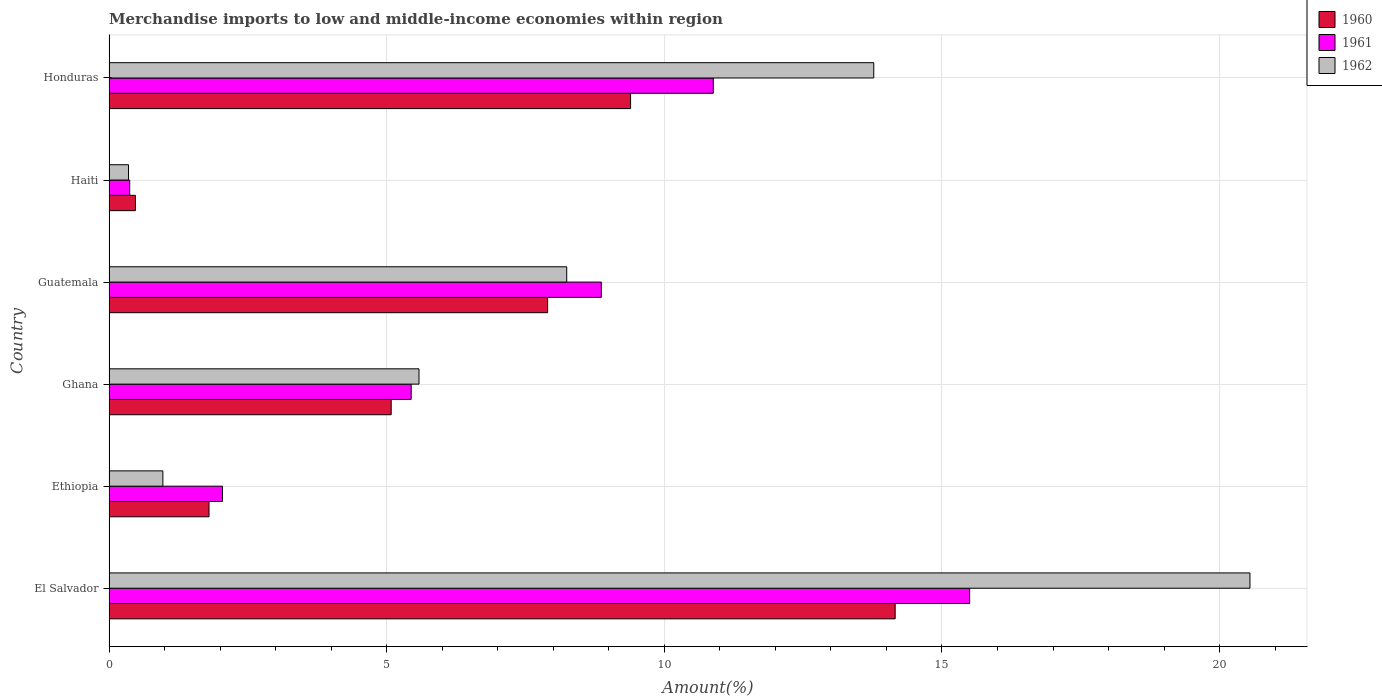How many groups of bars are there?
Ensure brevity in your answer.  6. Are the number of bars per tick equal to the number of legend labels?
Give a very brief answer. Yes. How many bars are there on the 5th tick from the top?
Your response must be concise. 3. How many bars are there on the 2nd tick from the bottom?
Your response must be concise. 3. What is the label of the 1st group of bars from the top?
Keep it short and to the point. Honduras. What is the percentage of amount earned from merchandise imports in 1961 in El Salvador?
Keep it short and to the point. 15.5. Across all countries, what is the maximum percentage of amount earned from merchandise imports in 1961?
Offer a terse response. 15.5. Across all countries, what is the minimum percentage of amount earned from merchandise imports in 1960?
Keep it short and to the point. 0.48. In which country was the percentage of amount earned from merchandise imports in 1961 maximum?
Offer a very short reply. El Salvador. In which country was the percentage of amount earned from merchandise imports in 1960 minimum?
Your answer should be very brief. Haiti. What is the total percentage of amount earned from merchandise imports in 1960 in the graph?
Provide a short and direct response. 38.81. What is the difference between the percentage of amount earned from merchandise imports in 1960 in El Salvador and that in Ethiopia?
Ensure brevity in your answer.  12.36. What is the difference between the percentage of amount earned from merchandise imports in 1962 in Guatemala and the percentage of amount earned from merchandise imports in 1960 in Ghana?
Your answer should be compact. 3.16. What is the average percentage of amount earned from merchandise imports in 1961 per country?
Your response must be concise. 7.18. What is the difference between the percentage of amount earned from merchandise imports in 1960 and percentage of amount earned from merchandise imports in 1962 in Guatemala?
Your answer should be very brief. -0.34. In how many countries, is the percentage of amount earned from merchandise imports in 1962 greater than 6 %?
Give a very brief answer. 3. What is the ratio of the percentage of amount earned from merchandise imports in 1960 in Ethiopia to that in Haiti?
Your response must be concise. 3.79. Is the difference between the percentage of amount earned from merchandise imports in 1960 in El Salvador and Haiti greater than the difference between the percentage of amount earned from merchandise imports in 1962 in El Salvador and Haiti?
Offer a very short reply. No. What is the difference between the highest and the second highest percentage of amount earned from merchandise imports in 1960?
Your response must be concise. 4.76. What is the difference between the highest and the lowest percentage of amount earned from merchandise imports in 1962?
Keep it short and to the point. 20.19. In how many countries, is the percentage of amount earned from merchandise imports in 1961 greater than the average percentage of amount earned from merchandise imports in 1961 taken over all countries?
Your response must be concise. 3. Is the sum of the percentage of amount earned from merchandise imports in 1962 in Ghana and Haiti greater than the maximum percentage of amount earned from merchandise imports in 1961 across all countries?
Offer a terse response. No. How many bars are there?
Offer a very short reply. 18. Are all the bars in the graph horizontal?
Give a very brief answer. Yes. How many countries are there in the graph?
Your answer should be compact. 6. What is the difference between two consecutive major ticks on the X-axis?
Give a very brief answer. 5. Does the graph contain any zero values?
Provide a succinct answer. No. How many legend labels are there?
Your response must be concise. 3. How are the legend labels stacked?
Offer a terse response. Vertical. What is the title of the graph?
Keep it short and to the point. Merchandise imports to low and middle-income economies within region. Does "2012" appear as one of the legend labels in the graph?
Provide a succinct answer. No. What is the label or title of the X-axis?
Make the answer very short. Amount(%). What is the Amount(%) of 1960 in El Salvador?
Your response must be concise. 14.16. What is the Amount(%) in 1961 in El Salvador?
Your response must be concise. 15.5. What is the Amount(%) of 1962 in El Salvador?
Give a very brief answer. 20.55. What is the Amount(%) in 1960 in Ethiopia?
Your answer should be very brief. 1.8. What is the Amount(%) of 1961 in Ethiopia?
Your response must be concise. 2.04. What is the Amount(%) of 1962 in Ethiopia?
Ensure brevity in your answer.  0.97. What is the Amount(%) in 1960 in Ghana?
Ensure brevity in your answer.  5.08. What is the Amount(%) of 1961 in Ghana?
Ensure brevity in your answer.  5.44. What is the Amount(%) of 1962 in Ghana?
Offer a terse response. 5.58. What is the Amount(%) in 1960 in Guatemala?
Your response must be concise. 7.9. What is the Amount(%) of 1961 in Guatemala?
Ensure brevity in your answer.  8.87. What is the Amount(%) in 1962 in Guatemala?
Offer a terse response. 8.24. What is the Amount(%) of 1960 in Haiti?
Provide a short and direct response. 0.48. What is the Amount(%) in 1961 in Haiti?
Your answer should be very brief. 0.37. What is the Amount(%) of 1962 in Haiti?
Make the answer very short. 0.35. What is the Amount(%) of 1960 in Honduras?
Keep it short and to the point. 9.39. What is the Amount(%) of 1961 in Honduras?
Provide a succinct answer. 10.88. What is the Amount(%) in 1962 in Honduras?
Make the answer very short. 13.77. Across all countries, what is the maximum Amount(%) of 1960?
Give a very brief answer. 14.16. Across all countries, what is the maximum Amount(%) of 1961?
Make the answer very short. 15.5. Across all countries, what is the maximum Amount(%) in 1962?
Your answer should be compact. 20.55. Across all countries, what is the minimum Amount(%) in 1960?
Provide a succinct answer. 0.48. Across all countries, what is the minimum Amount(%) in 1961?
Offer a very short reply. 0.37. Across all countries, what is the minimum Amount(%) in 1962?
Offer a very short reply. 0.35. What is the total Amount(%) of 1960 in the graph?
Your answer should be compact. 38.81. What is the total Amount(%) of 1961 in the graph?
Your answer should be compact. 43.1. What is the total Amount(%) of 1962 in the graph?
Your answer should be very brief. 49.46. What is the difference between the Amount(%) of 1960 in El Salvador and that in Ethiopia?
Offer a very short reply. 12.36. What is the difference between the Amount(%) of 1961 in El Salvador and that in Ethiopia?
Keep it short and to the point. 13.46. What is the difference between the Amount(%) in 1962 in El Salvador and that in Ethiopia?
Provide a short and direct response. 19.58. What is the difference between the Amount(%) in 1960 in El Salvador and that in Ghana?
Provide a succinct answer. 9.08. What is the difference between the Amount(%) in 1961 in El Salvador and that in Ghana?
Your response must be concise. 10.06. What is the difference between the Amount(%) in 1962 in El Salvador and that in Ghana?
Your answer should be compact. 14.96. What is the difference between the Amount(%) in 1960 in El Salvador and that in Guatemala?
Offer a terse response. 6.26. What is the difference between the Amount(%) of 1961 in El Salvador and that in Guatemala?
Provide a short and direct response. 6.63. What is the difference between the Amount(%) of 1962 in El Salvador and that in Guatemala?
Give a very brief answer. 12.3. What is the difference between the Amount(%) in 1960 in El Salvador and that in Haiti?
Offer a terse response. 13.68. What is the difference between the Amount(%) of 1961 in El Salvador and that in Haiti?
Your answer should be very brief. 15.13. What is the difference between the Amount(%) in 1962 in El Salvador and that in Haiti?
Your answer should be compact. 20.19. What is the difference between the Amount(%) of 1960 in El Salvador and that in Honduras?
Keep it short and to the point. 4.76. What is the difference between the Amount(%) of 1961 in El Salvador and that in Honduras?
Your answer should be compact. 4.62. What is the difference between the Amount(%) of 1962 in El Salvador and that in Honduras?
Your answer should be compact. 6.77. What is the difference between the Amount(%) in 1960 in Ethiopia and that in Ghana?
Keep it short and to the point. -3.28. What is the difference between the Amount(%) of 1961 in Ethiopia and that in Ghana?
Your response must be concise. -3.4. What is the difference between the Amount(%) in 1962 in Ethiopia and that in Ghana?
Make the answer very short. -4.61. What is the difference between the Amount(%) of 1960 in Ethiopia and that in Guatemala?
Your answer should be compact. -6.1. What is the difference between the Amount(%) in 1961 in Ethiopia and that in Guatemala?
Make the answer very short. -6.82. What is the difference between the Amount(%) of 1962 in Ethiopia and that in Guatemala?
Your answer should be compact. -7.27. What is the difference between the Amount(%) in 1960 in Ethiopia and that in Haiti?
Your response must be concise. 1.33. What is the difference between the Amount(%) in 1961 in Ethiopia and that in Haiti?
Provide a short and direct response. 1.67. What is the difference between the Amount(%) of 1962 in Ethiopia and that in Haiti?
Provide a succinct answer. 0.62. What is the difference between the Amount(%) of 1960 in Ethiopia and that in Honduras?
Provide a succinct answer. -7.59. What is the difference between the Amount(%) of 1961 in Ethiopia and that in Honduras?
Ensure brevity in your answer.  -8.84. What is the difference between the Amount(%) of 1962 in Ethiopia and that in Honduras?
Make the answer very short. -12.8. What is the difference between the Amount(%) of 1960 in Ghana and that in Guatemala?
Provide a succinct answer. -2.82. What is the difference between the Amount(%) of 1961 in Ghana and that in Guatemala?
Your response must be concise. -3.42. What is the difference between the Amount(%) in 1962 in Ghana and that in Guatemala?
Offer a very short reply. -2.66. What is the difference between the Amount(%) in 1960 in Ghana and that in Haiti?
Your answer should be very brief. 4.61. What is the difference between the Amount(%) of 1961 in Ghana and that in Haiti?
Your response must be concise. 5.07. What is the difference between the Amount(%) in 1962 in Ghana and that in Haiti?
Your answer should be very brief. 5.23. What is the difference between the Amount(%) of 1960 in Ghana and that in Honduras?
Provide a short and direct response. -4.31. What is the difference between the Amount(%) of 1961 in Ghana and that in Honduras?
Offer a very short reply. -5.44. What is the difference between the Amount(%) of 1962 in Ghana and that in Honduras?
Provide a succinct answer. -8.19. What is the difference between the Amount(%) in 1960 in Guatemala and that in Haiti?
Make the answer very short. 7.42. What is the difference between the Amount(%) in 1961 in Guatemala and that in Haiti?
Offer a very short reply. 8.49. What is the difference between the Amount(%) in 1962 in Guatemala and that in Haiti?
Provide a succinct answer. 7.89. What is the difference between the Amount(%) of 1960 in Guatemala and that in Honduras?
Ensure brevity in your answer.  -1.49. What is the difference between the Amount(%) in 1961 in Guatemala and that in Honduras?
Give a very brief answer. -2.02. What is the difference between the Amount(%) in 1962 in Guatemala and that in Honduras?
Your response must be concise. -5.53. What is the difference between the Amount(%) of 1960 in Haiti and that in Honduras?
Provide a succinct answer. -8.92. What is the difference between the Amount(%) of 1961 in Haiti and that in Honduras?
Keep it short and to the point. -10.51. What is the difference between the Amount(%) of 1962 in Haiti and that in Honduras?
Your response must be concise. -13.42. What is the difference between the Amount(%) in 1960 in El Salvador and the Amount(%) in 1961 in Ethiopia?
Provide a succinct answer. 12.11. What is the difference between the Amount(%) of 1960 in El Salvador and the Amount(%) of 1962 in Ethiopia?
Your answer should be compact. 13.19. What is the difference between the Amount(%) of 1961 in El Salvador and the Amount(%) of 1962 in Ethiopia?
Offer a terse response. 14.53. What is the difference between the Amount(%) of 1960 in El Salvador and the Amount(%) of 1961 in Ghana?
Your answer should be very brief. 8.72. What is the difference between the Amount(%) of 1960 in El Salvador and the Amount(%) of 1962 in Ghana?
Make the answer very short. 8.57. What is the difference between the Amount(%) of 1961 in El Salvador and the Amount(%) of 1962 in Ghana?
Offer a terse response. 9.92. What is the difference between the Amount(%) of 1960 in El Salvador and the Amount(%) of 1961 in Guatemala?
Give a very brief answer. 5.29. What is the difference between the Amount(%) of 1960 in El Salvador and the Amount(%) of 1962 in Guatemala?
Offer a very short reply. 5.92. What is the difference between the Amount(%) of 1961 in El Salvador and the Amount(%) of 1962 in Guatemala?
Provide a short and direct response. 7.26. What is the difference between the Amount(%) of 1960 in El Salvador and the Amount(%) of 1961 in Haiti?
Ensure brevity in your answer.  13.78. What is the difference between the Amount(%) in 1960 in El Salvador and the Amount(%) in 1962 in Haiti?
Keep it short and to the point. 13.81. What is the difference between the Amount(%) of 1961 in El Salvador and the Amount(%) of 1962 in Haiti?
Ensure brevity in your answer.  15.15. What is the difference between the Amount(%) of 1960 in El Salvador and the Amount(%) of 1961 in Honduras?
Keep it short and to the point. 3.28. What is the difference between the Amount(%) in 1960 in El Salvador and the Amount(%) in 1962 in Honduras?
Your response must be concise. 0.39. What is the difference between the Amount(%) of 1961 in El Salvador and the Amount(%) of 1962 in Honduras?
Keep it short and to the point. 1.73. What is the difference between the Amount(%) of 1960 in Ethiopia and the Amount(%) of 1961 in Ghana?
Your answer should be compact. -3.64. What is the difference between the Amount(%) in 1960 in Ethiopia and the Amount(%) in 1962 in Ghana?
Provide a succinct answer. -3.78. What is the difference between the Amount(%) in 1961 in Ethiopia and the Amount(%) in 1962 in Ghana?
Your answer should be compact. -3.54. What is the difference between the Amount(%) of 1960 in Ethiopia and the Amount(%) of 1961 in Guatemala?
Your answer should be very brief. -7.06. What is the difference between the Amount(%) of 1960 in Ethiopia and the Amount(%) of 1962 in Guatemala?
Keep it short and to the point. -6.44. What is the difference between the Amount(%) in 1961 in Ethiopia and the Amount(%) in 1962 in Guatemala?
Provide a succinct answer. -6.2. What is the difference between the Amount(%) in 1960 in Ethiopia and the Amount(%) in 1961 in Haiti?
Your response must be concise. 1.43. What is the difference between the Amount(%) in 1960 in Ethiopia and the Amount(%) in 1962 in Haiti?
Your answer should be very brief. 1.45. What is the difference between the Amount(%) in 1961 in Ethiopia and the Amount(%) in 1962 in Haiti?
Your response must be concise. 1.69. What is the difference between the Amount(%) of 1960 in Ethiopia and the Amount(%) of 1961 in Honduras?
Ensure brevity in your answer.  -9.08. What is the difference between the Amount(%) of 1960 in Ethiopia and the Amount(%) of 1962 in Honduras?
Give a very brief answer. -11.97. What is the difference between the Amount(%) in 1961 in Ethiopia and the Amount(%) in 1962 in Honduras?
Offer a terse response. -11.73. What is the difference between the Amount(%) of 1960 in Ghana and the Amount(%) of 1961 in Guatemala?
Your answer should be compact. -3.78. What is the difference between the Amount(%) in 1960 in Ghana and the Amount(%) in 1962 in Guatemala?
Make the answer very short. -3.16. What is the difference between the Amount(%) of 1961 in Ghana and the Amount(%) of 1962 in Guatemala?
Offer a very short reply. -2.8. What is the difference between the Amount(%) of 1960 in Ghana and the Amount(%) of 1961 in Haiti?
Your answer should be compact. 4.71. What is the difference between the Amount(%) in 1960 in Ghana and the Amount(%) in 1962 in Haiti?
Make the answer very short. 4.73. What is the difference between the Amount(%) of 1961 in Ghana and the Amount(%) of 1962 in Haiti?
Give a very brief answer. 5.09. What is the difference between the Amount(%) in 1960 in Ghana and the Amount(%) in 1961 in Honduras?
Make the answer very short. -5.8. What is the difference between the Amount(%) in 1960 in Ghana and the Amount(%) in 1962 in Honduras?
Keep it short and to the point. -8.69. What is the difference between the Amount(%) of 1961 in Ghana and the Amount(%) of 1962 in Honduras?
Provide a short and direct response. -8.33. What is the difference between the Amount(%) of 1960 in Guatemala and the Amount(%) of 1961 in Haiti?
Your response must be concise. 7.53. What is the difference between the Amount(%) in 1960 in Guatemala and the Amount(%) in 1962 in Haiti?
Your response must be concise. 7.55. What is the difference between the Amount(%) of 1961 in Guatemala and the Amount(%) of 1962 in Haiti?
Make the answer very short. 8.51. What is the difference between the Amount(%) of 1960 in Guatemala and the Amount(%) of 1961 in Honduras?
Your answer should be compact. -2.98. What is the difference between the Amount(%) in 1960 in Guatemala and the Amount(%) in 1962 in Honduras?
Your answer should be compact. -5.87. What is the difference between the Amount(%) in 1961 in Guatemala and the Amount(%) in 1962 in Honduras?
Offer a very short reply. -4.91. What is the difference between the Amount(%) of 1960 in Haiti and the Amount(%) of 1961 in Honduras?
Offer a terse response. -10.41. What is the difference between the Amount(%) of 1960 in Haiti and the Amount(%) of 1962 in Honduras?
Provide a short and direct response. -13.3. What is the difference between the Amount(%) in 1961 in Haiti and the Amount(%) in 1962 in Honduras?
Offer a very short reply. -13.4. What is the average Amount(%) in 1960 per country?
Give a very brief answer. 6.47. What is the average Amount(%) of 1961 per country?
Make the answer very short. 7.18. What is the average Amount(%) in 1962 per country?
Provide a short and direct response. 8.24. What is the difference between the Amount(%) in 1960 and Amount(%) in 1961 in El Salvador?
Offer a very short reply. -1.34. What is the difference between the Amount(%) in 1960 and Amount(%) in 1962 in El Salvador?
Your answer should be compact. -6.39. What is the difference between the Amount(%) of 1961 and Amount(%) of 1962 in El Salvador?
Your answer should be compact. -5.05. What is the difference between the Amount(%) in 1960 and Amount(%) in 1961 in Ethiopia?
Keep it short and to the point. -0.24. What is the difference between the Amount(%) of 1960 and Amount(%) of 1962 in Ethiopia?
Provide a succinct answer. 0.83. What is the difference between the Amount(%) of 1961 and Amount(%) of 1962 in Ethiopia?
Ensure brevity in your answer.  1.07. What is the difference between the Amount(%) of 1960 and Amount(%) of 1961 in Ghana?
Give a very brief answer. -0.36. What is the difference between the Amount(%) in 1960 and Amount(%) in 1962 in Ghana?
Provide a succinct answer. -0.5. What is the difference between the Amount(%) of 1961 and Amount(%) of 1962 in Ghana?
Your response must be concise. -0.14. What is the difference between the Amount(%) of 1960 and Amount(%) of 1961 in Guatemala?
Give a very brief answer. -0.97. What is the difference between the Amount(%) in 1960 and Amount(%) in 1962 in Guatemala?
Ensure brevity in your answer.  -0.34. What is the difference between the Amount(%) in 1961 and Amount(%) in 1962 in Guatemala?
Provide a short and direct response. 0.62. What is the difference between the Amount(%) in 1960 and Amount(%) in 1961 in Haiti?
Offer a very short reply. 0.1. What is the difference between the Amount(%) of 1960 and Amount(%) of 1962 in Haiti?
Provide a succinct answer. 0.12. What is the difference between the Amount(%) of 1961 and Amount(%) of 1962 in Haiti?
Your answer should be very brief. 0.02. What is the difference between the Amount(%) of 1960 and Amount(%) of 1961 in Honduras?
Give a very brief answer. -1.49. What is the difference between the Amount(%) of 1960 and Amount(%) of 1962 in Honduras?
Your response must be concise. -4.38. What is the difference between the Amount(%) of 1961 and Amount(%) of 1962 in Honduras?
Your response must be concise. -2.89. What is the ratio of the Amount(%) of 1960 in El Salvador to that in Ethiopia?
Your answer should be very brief. 7.86. What is the ratio of the Amount(%) of 1961 in El Salvador to that in Ethiopia?
Offer a very short reply. 7.59. What is the ratio of the Amount(%) in 1962 in El Salvador to that in Ethiopia?
Provide a succinct answer. 21.18. What is the ratio of the Amount(%) in 1960 in El Salvador to that in Ghana?
Your response must be concise. 2.79. What is the ratio of the Amount(%) of 1961 in El Salvador to that in Ghana?
Your response must be concise. 2.85. What is the ratio of the Amount(%) of 1962 in El Salvador to that in Ghana?
Provide a short and direct response. 3.68. What is the ratio of the Amount(%) of 1960 in El Salvador to that in Guatemala?
Offer a very short reply. 1.79. What is the ratio of the Amount(%) in 1961 in El Salvador to that in Guatemala?
Offer a very short reply. 1.75. What is the ratio of the Amount(%) in 1962 in El Salvador to that in Guatemala?
Your answer should be compact. 2.49. What is the ratio of the Amount(%) in 1960 in El Salvador to that in Haiti?
Give a very brief answer. 29.76. What is the ratio of the Amount(%) of 1961 in El Salvador to that in Haiti?
Make the answer very short. 41.56. What is the ratio of the Amount(%) in 1962 in El Salvador to that in Haiti?
Provide a succinct answer. 58.51. What is the ratio of the Amount(%) of 1960 in El Salvador to that in Honduras?
Provide a short and direct response. 1.51. What is the ratio of the Amount(%) of 1961 in El Salvador to that in Honduras?
Ensure brevity in your answer.  1.42. What is the ratio of the Amount(%) of 1962 in El Salvador to that in Honduras?
Keep it short and to the point. 1.49. What is the ratio of the Amount(%) of 1960 in Ethiopia to that in Ghana?
Your answer should be very brief. 0.35. What is the ratio of the Amount(%) of 1961 in Ethiopia to that in Ghana?
Your response must be concise. 0.38. What is the ratio of the Amount(%) of 1962 in Ethiopia to that in Ghana?
Your response must be concise. 0.17. What is the ratio of the Amount(%) in 1960 in Ethiopia to that in Guatemala?
Your answer should be very brief. 0.23. What is the ratio of the Amount(%) in 1961 in Ethiopia to that in Guatemala?
Ensure brevity in your answer.  0.23. What is the ratio of the Amount(%) in 1962 in Ethiopia to that in Guatemala?
Provide a short and direct response. 0.12. What is the ratio of the Amount(%) of 1960 in Ethiopia to that in Haiti?
Provide a succinct answer. 3.79. What is the ratio of the Amount(%) of 1961 in Ethiopia to that in Haiti?
Your response must be concise. 5.48. What is the ratio of the Amount(%) in 1962 in Ethiopia to that in Haiti?
Provide a short and direct response. 2.76. What is the ratio of the Amount(%) in 1960 in Ethiopia to that in Honduras?
Make the answer very short. 0.19. What is the ratio of the Amount(%) of 1961 in Ethiopia to that in Honduras?
Keep it short and to the point. 0.19. What is the ratio of the Amount(%) of 1962 in Ethiopia to that in Honduras?
Your response must be concise. 0.07. What is the ratio of the Amount(%) in 1960 in Ghana to that in Guatemala?
Offer a terse response. 0.64. What is the ratio of the Amount(%) of 1961 in Ghana to that in Guatemala?
Your answer should be very brief. 0.61. What is the ratio of the Amount(%) of 1962 in Ghana to that in Guatemala?
Keep it short and to the point. 0.68. What is the ratio of the Amount(%) of 1960 in Ghana to that in Haiti?
Offer a very short reply. 10.68. What is the ratio of the Amount(%) of 1961 in Ghana to that in Haiti?
Provide a short and direct response. 14.59. What is the ratio of the Amount(%) of 1962 in Ghana to that in Haiti?
Provide a short and direct response. 15.9. What is the ratio of the Amount(%) of 1960 in Ghana to that in Honduras?
Your response must be concise. 0.54. What is the ratio of the Amount(%) of 1961 in Ghana to that in Honduras?
Provide a succinct answer. 0.5. What is the ratio of the Amount(%) of 1962 in Ghana to that in Honduras?
Provide a short and direct response. 0.41. What is the ratio of the Amount(%) in 1960 in Guatemala to that in Haiti?
Offer a very short reply. 16.61. What is the ratio of the Amount(%) in 1961 in Guatemala to that in Haiti?
Keep it short and to the point. 23.77. What is the ratio of the Amount(%) of 1962 in Guatemala to that in Haiti?
Your answer should be compact. 23.47. What is the ratio of the Amount(%) in 1960 in Guatemala to that in Honduras?
Make the answer very short. 0.84. What is the ratio of the Amount(%) in 1961 in Guatemala to that in Honduras?
Provide a succinct answer. 0.81. What is the ratio of the Amount(%) of 1962 in Guatemala to that in Honduras?
Offer a very short reply. 0.6. What is the ratio of the Amount(%) in 1960 in Haiti to that in Honduras?
Your answer should be compact. 0.05. What is the ratio of the Amount(%) of 1961 in Haiti to that in Honduras?
Keep it short and to the point. 0.03. What is the ratio of the Amount(%) in 1962 in Haiti to that in Honduras?
Provide a short and direct response. 0.03. What is the difference between the highest and the second highest Amount(%) in 1960?
Provide a short and direct response. 4.76. What is the difference between the highest and the second highest Amount(%) of 1961?
Provide a succinct answer. 4.62. What is the difference between the highest and the second highest Amount(%) of 1962?
Your answer should be very brief. 6.77. What is the difference between the highest and the lowest Amount(%) of 1960?
Give a very brief answer. 13.68. What is the difference between the highest and the lowest Amount(%) in 1961?
Your answer should be compact. 15.13. What is the difference between the highest and the lowest Amount(%) in 1962?
Your answer should be very brief. 20.19. 